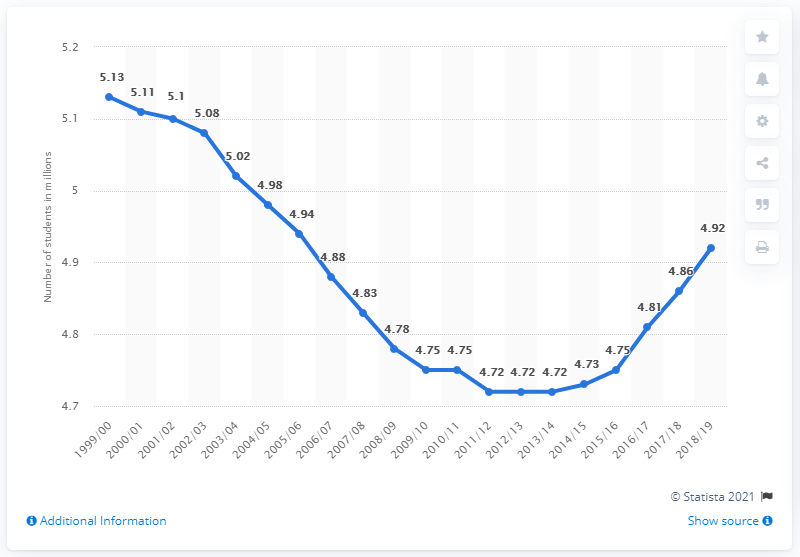Specify some key components in this picture. In the 2018/19 school year, a total of 4.92 million students were enrolled in public elementary and secondary schools in Canada. 